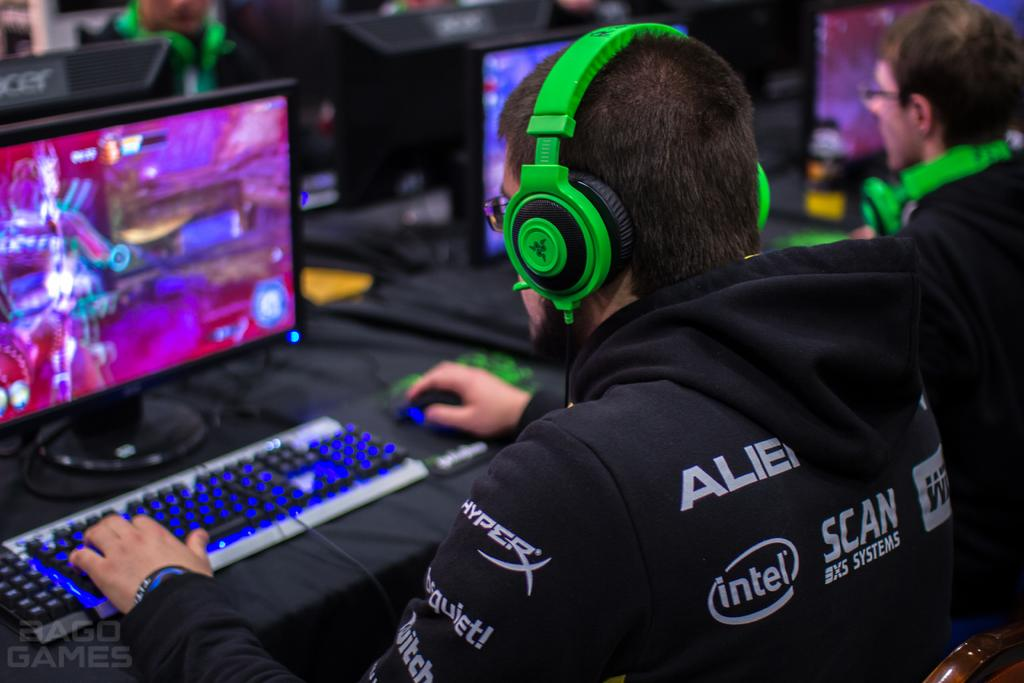<image>
Describe the image concisely. Man playing video games with headphones on and a hoodie for intel. 